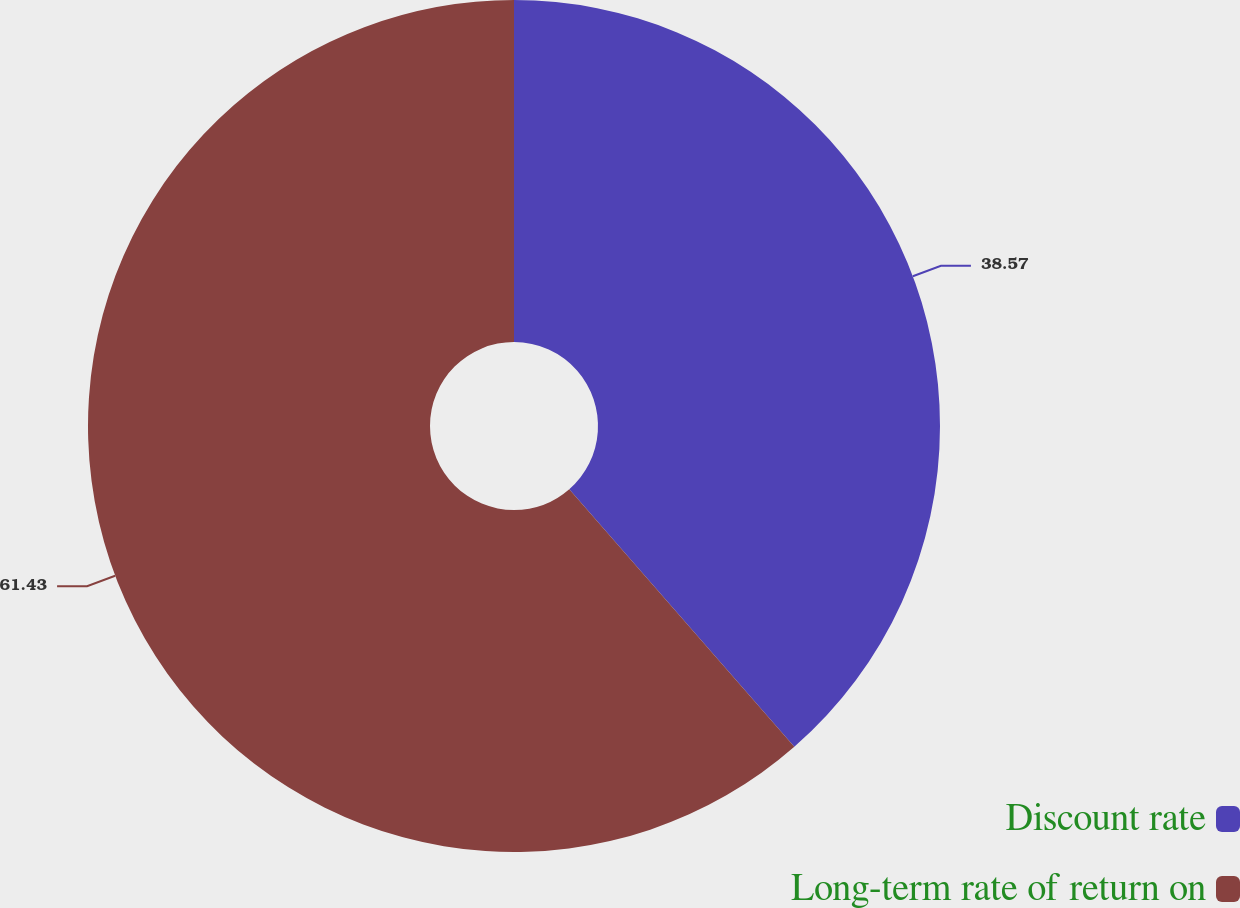<chart> <loc_0><loc_0><loc_500><loc_500><pie_chart><fcel>Discount rate<fcel>Long-term rate of return on<nl><fcel>38.57%<fcel>61.43%<nl></chart> 